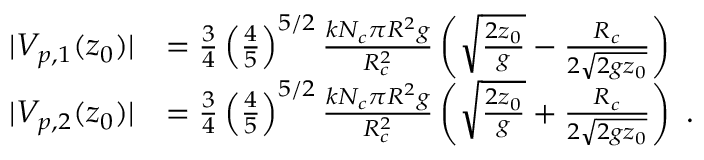<formula> <loc_0><loc_0><loc_500><loc_500>\begin{array} { r l } { | V _ { p , 1 } ( z _ { 0 } ) | } & { = \frac { 3 } { 4 } \left ( \frac { 4 } { 5 } \right ) ^ { 5 / 2 } \frac { k N _ { c } \pi R ^ { 2 } g } { R _ { c } ^ { 2 } } \left ( \sqrt { \frac { 2 z _ { 0 } } { g } } - \frac { R _ { c } } { 2 \sqrt { 2 g z _ { 0 } } } \right ) } \\ { | V _ { p , 2 } ( z _ { 0 } ) | } & { = \frac { 3 } { 4 } \left ( \frac { 4 } { 5 } \right ) ^ { 5 / 2 } \frac { k N _ { c } \pi R ^ { 2 } g } { R _ { c } ^ { 2 } } \left ( \sqrt { \frac { 2 z _ { 0 } } { g } } + \frac { R _ { c } } { 2 \sqrt { 2 g z _ { 0 } } } \right ) \, . } \end{array}</formula> 